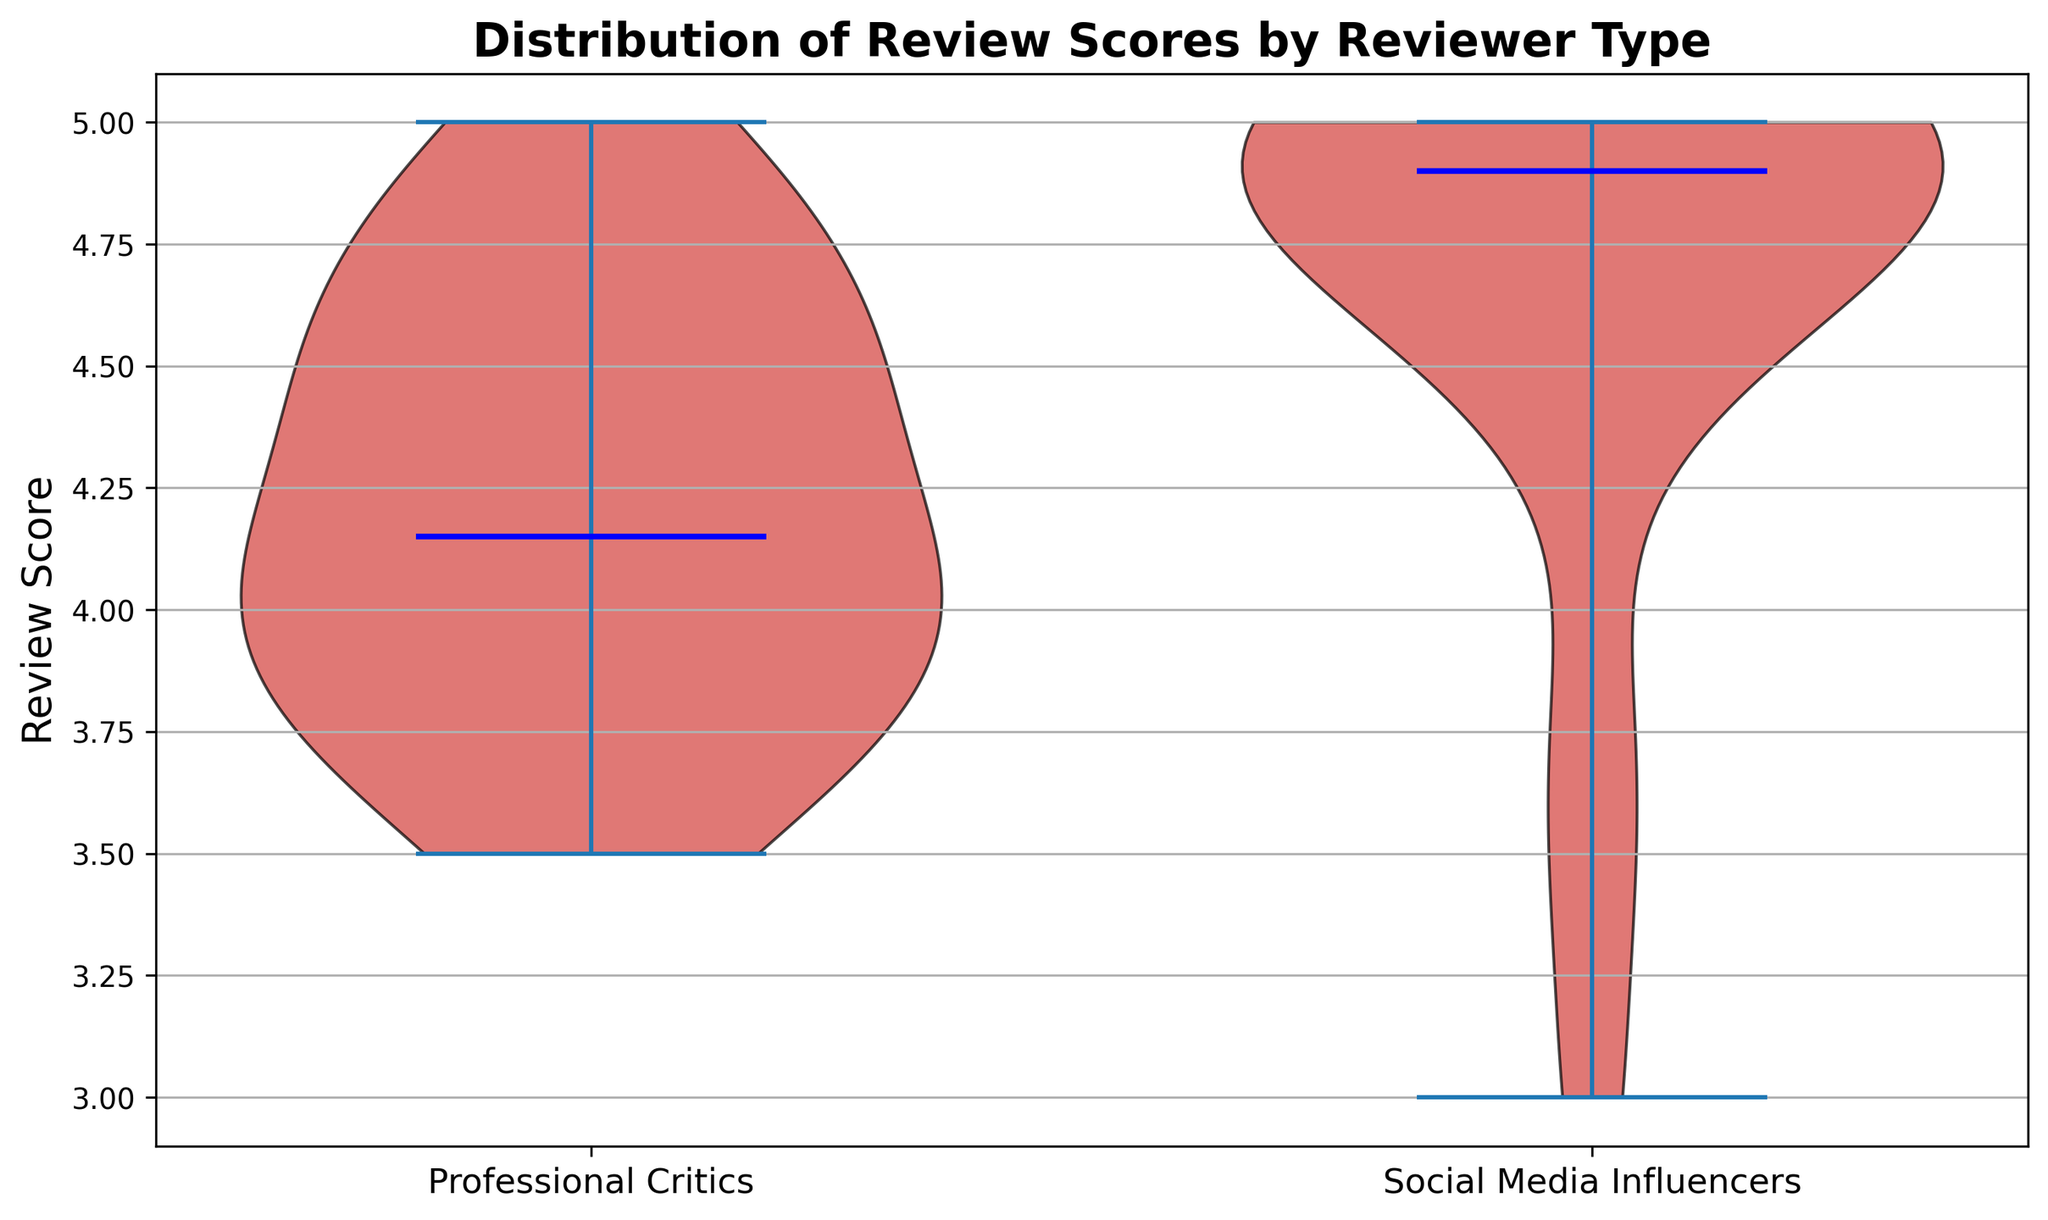What's the median review score for professional critics? The median in a violin plot is indicated by a horizontal line within the plot. For professional critics, look at the middle value in the distribution.
Answer: 4.1 What's the range of review scores given by social media influencers? The range is determined by the difference between the maximum and minimum values in the distribution. For social media influencers, locate the top and bottom edges of the plot.
Answer: 2.0 Which group has a higher median review score? Compare the horizontal lines indicating the medians in both violin plots. The position of the line for social media influencers is higher than that of professional critics.
Answer: Social Media Influencers How do the spread of review scores compare between the two groups? The spread is indicated by the width and range of the violin plots. The social media influencers' plot extends more and is generally wider at many points, indicating a larger spread.
Answer: Social Media Influencers have a wider spread Which group shows more variation in their review scores? Variation is indicated by the extent of the distribution in the violin plot. The social media influencers' plot covers a broader range and is less tight compared to the professional critics'.
Answer: Social Media Influencers Are there any review scores that are outliers for professional critics? Outliers would be visible as points outside the main body of the violin plot. Check for any points that are surprisedly far from the general shape for professional critics.
Answer: No Which group's lower quartile review scores are higher? The lower quartile is seen in the lower part of the distribution. For the professional critics, the lower part of the plot starts higher compared to the social media influencers.
Answer: Professional Critics 